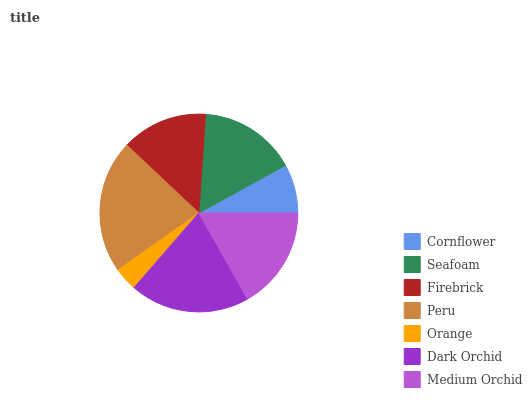Is Orange the minimum?
Answer yes or no. Yes. Is Peru the maximum?
Answer yes or no. Yes. Is Seafoam the minimum?
Answer yes or no. No. Is Seafoam the maximum?
Answer yes or no. No. Is Seafoam greater than Cornflower?
Answer yes or no. Yes. Is Cornflower less than Seafoam?
Answer yes or no. Yes. Is Cornflower greater than Seafoam?
Answer yes or no. No. Is Seafoam less than Cornflower?
Answer yes or no. No. Is Seafoam the high median?
Answer yes or no. Yes. Is Seafoam the low median?
Answer yes or no. Yes. Is Peru the high median?
Answer yes or no. No. Is Cornflower the low median?
Answer yes or no. No. 